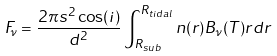Convert formula to latex. <formula><loc_0><loc_0><loc_500><loc_500>F _ { \nu } = \frac { 2 \pi s ^ { 2 } \cos ( i ) } { d ^ { 2 } } \int ^ { R _ { t i d a l } } _ { R _ { s u b } } n ( r ) B _ { \nu } ( T ) r d r</formula> 